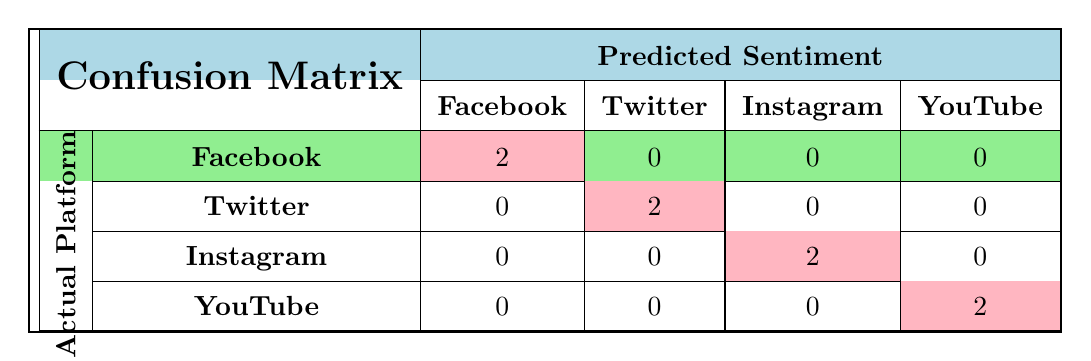What is the predicted sentiment for Facebook based on the confusion matrix? According to the confusion matrix, Facebook has 2 positive sentiments predicted and 0 negative sentiments predicted. Hence, the predicted sentiment for Facebook is associated primarily with positive feedback.
Answer: Positive How many total entries are there for the actual platform Instagram? The confusion matrix shows that there are 2 entries for Instagram (one for each sentiment: positive and negative). Thus, the total entries for Instagram are 2.
Answer: 2 Which platform has the highest count of negative feedback predictions? The matrix shows 0 negative predictions for all platforms except YouTube, which has 2 negative predictions. Therefore, YouTube has the highest count of negative feedback predictions.
Answer: YouTube What is the total number of entries for the platform Twitter? The confusion matrix indicates that Twitter has 2 entries (both related to its actual usage with positive and negative sentiments). Thus, the total number of entries for Twitter is 2.
Answer: 2 Is there any platform that has positive sentiment predictions for other platforms? The confusion matrix indicates that each platform has 2 positive sentiments predicted only for itself and none for the others. Hence, there is no platform that has positive predictions for other platforms.
Answer: No How many platforms received negative sentiment predictions in total? From the confusion matrix, only YouTube and Twitter have been given negative predictions, with 2 negatives for each. Thus, only these platforms contributed to the total count of negative sentiment predictions, leading to a total of 2 platforms.
Answer: 2 If you combine the positive sentiment predictions from all platforms, what would be the total? The confusion matrix shows 2 positive predictions from each platform (Facebook, Twitter, Instagram, and YouTube), which gives a total of 2 + 2 + 2 + 2 = 8. Thus, the combination of all positive sentiment predictions from the platforms results in a total of 8.
Answer: 8 Does the confusion matrix indicate that any of the platforms has equal positive and negative predictions? The confusion matrix displays that each platform has 2 positive predictions and 0 negative predictions, which shows that no platform has equal predictions. Therefore, there are no platforms that have equal positive and negative predictions.
Answer: No 